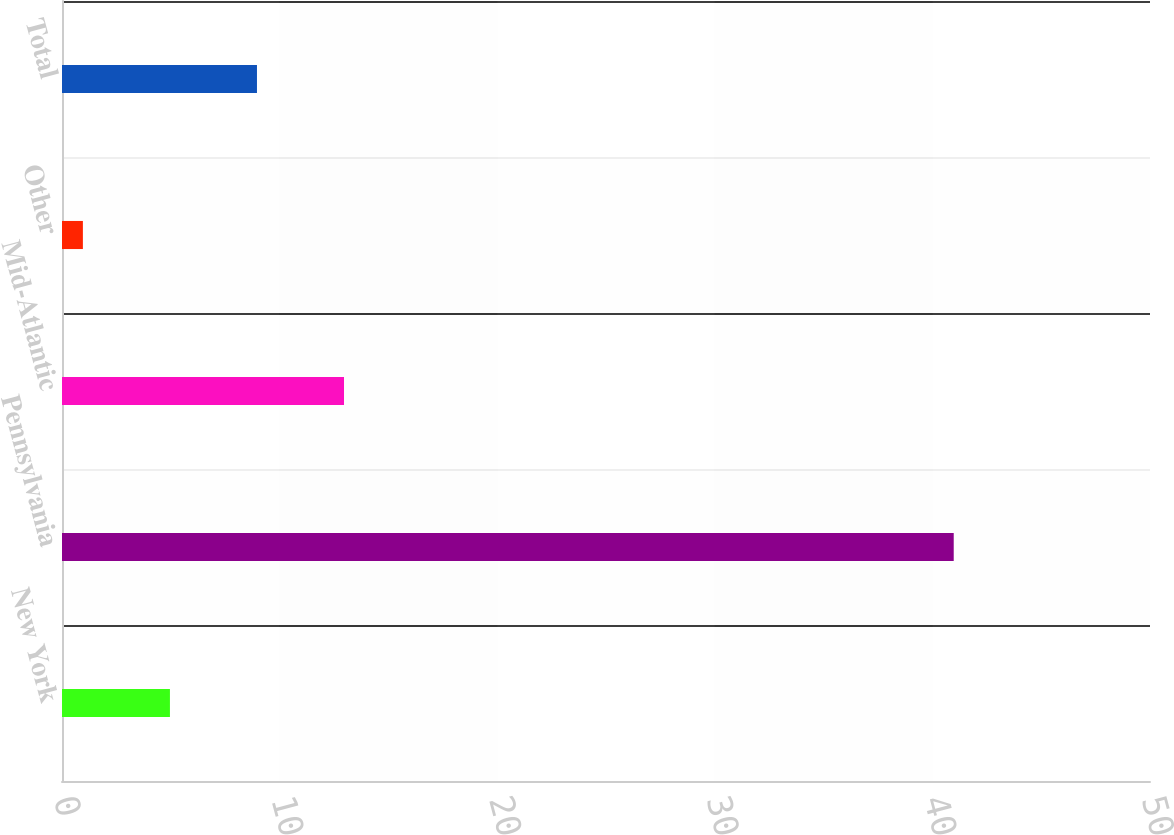Convert chart to OTSL. <chart><loc_0><loc_0><loc_500><loc_500><bar_chart><fcel>New York<fcel>Pennsylvania<fcel>Mid-Atlantic<fcel>Other<fcel>Total<nl><fcel>4.96<fcel>40.98<fcel>12.96<fcel>0.96<fcel>8.96<nl></chart> 